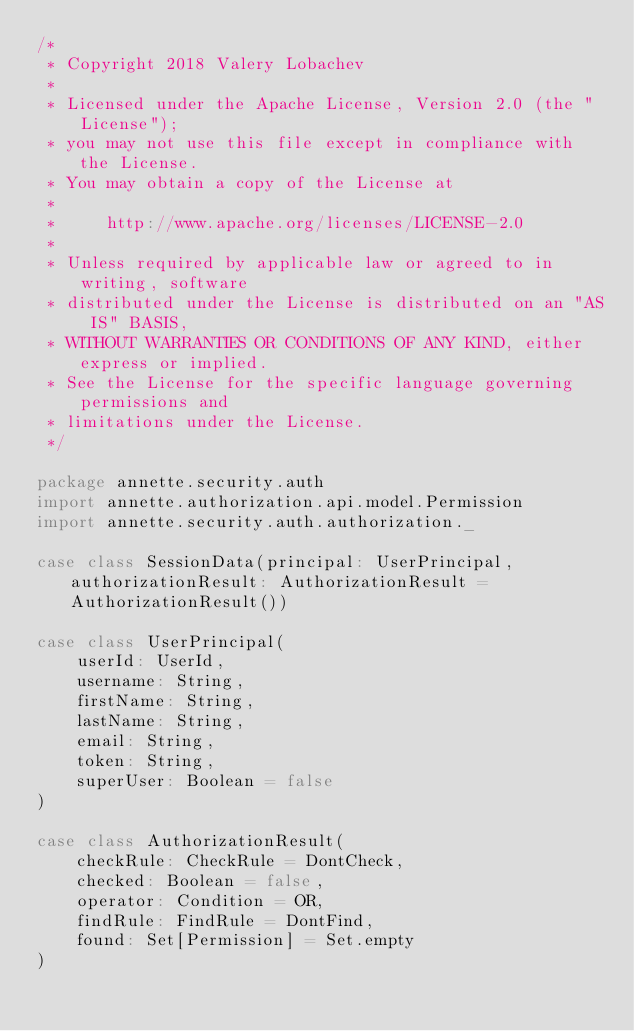Convert code to text. <code><loc_0><loc_0><loc_500><loc_500><_Scala_>/*
 * Copyright 2018 Valery Lobachev
 *
 * Licensed under the Apache License, Version 2.0 (the "License");
 * you may not use this file except in compliance with the License.
 * You may obtain a copy of the License at
 *
 *     http://www.apache.org/licenses/LICENSE-2.0
 *
 * Unless required by applicable law or agreed to in writing, software
 * distributed under the License is distributed on an "AS IS" BASIS,
 * WITHOUT WARRANTIES OR CONDITIONS OF ANY KIND, either express or implied.
 * See the License for the specific language governing permissions and
 * limitations under the License.
 */

package annette.security.auth
import annette.authorization.api.model.Permission
import annette.security.auth.authorization._

case class SessionData(principal: UserPrincipal, authorizationResult: AuthorizationResult = AuthorizationResult())

case class UserPrincipal(
    userId: UserId,
    username: String,
    firstName: String,
    lastName: String,
    email: String,
    token: String,
    superUser: Boolean = false
)

case class AuthorizationResult(
    checkRule: CheckRule = DontCheck,
    checked: Boolean = false,
    operator: Condition = OR,
    findRule: FindRule = DontFind,
    found: Set[Permission] = Set.empty
)
</code> 